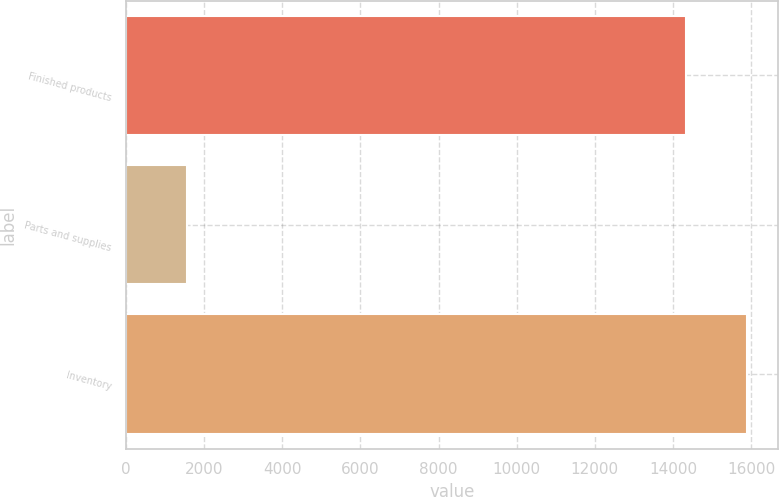Convert chart to OTSL. <chart><loc_0><loc_0><loc_500><loc_500><bar_chart><fcel>Finished products<fcel>Parts and supplies<fcel>Inventory<nl><fcel>14321<fcel>1567<fcel>15888<nl></chart> 